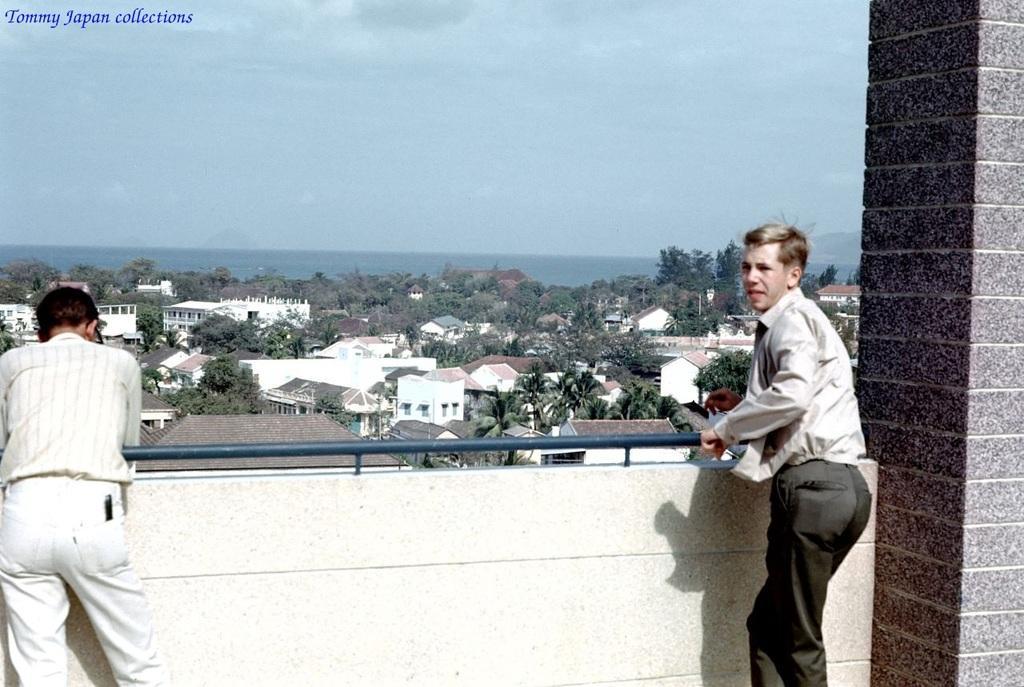Please provide a concise description of this image. In this image there is one person standing on the left side of this image and one person standing on the right side of this image as well. There is a wall in the bottom of this image. There are some trees and buildings in the background. There is a sky on the top of this image. 